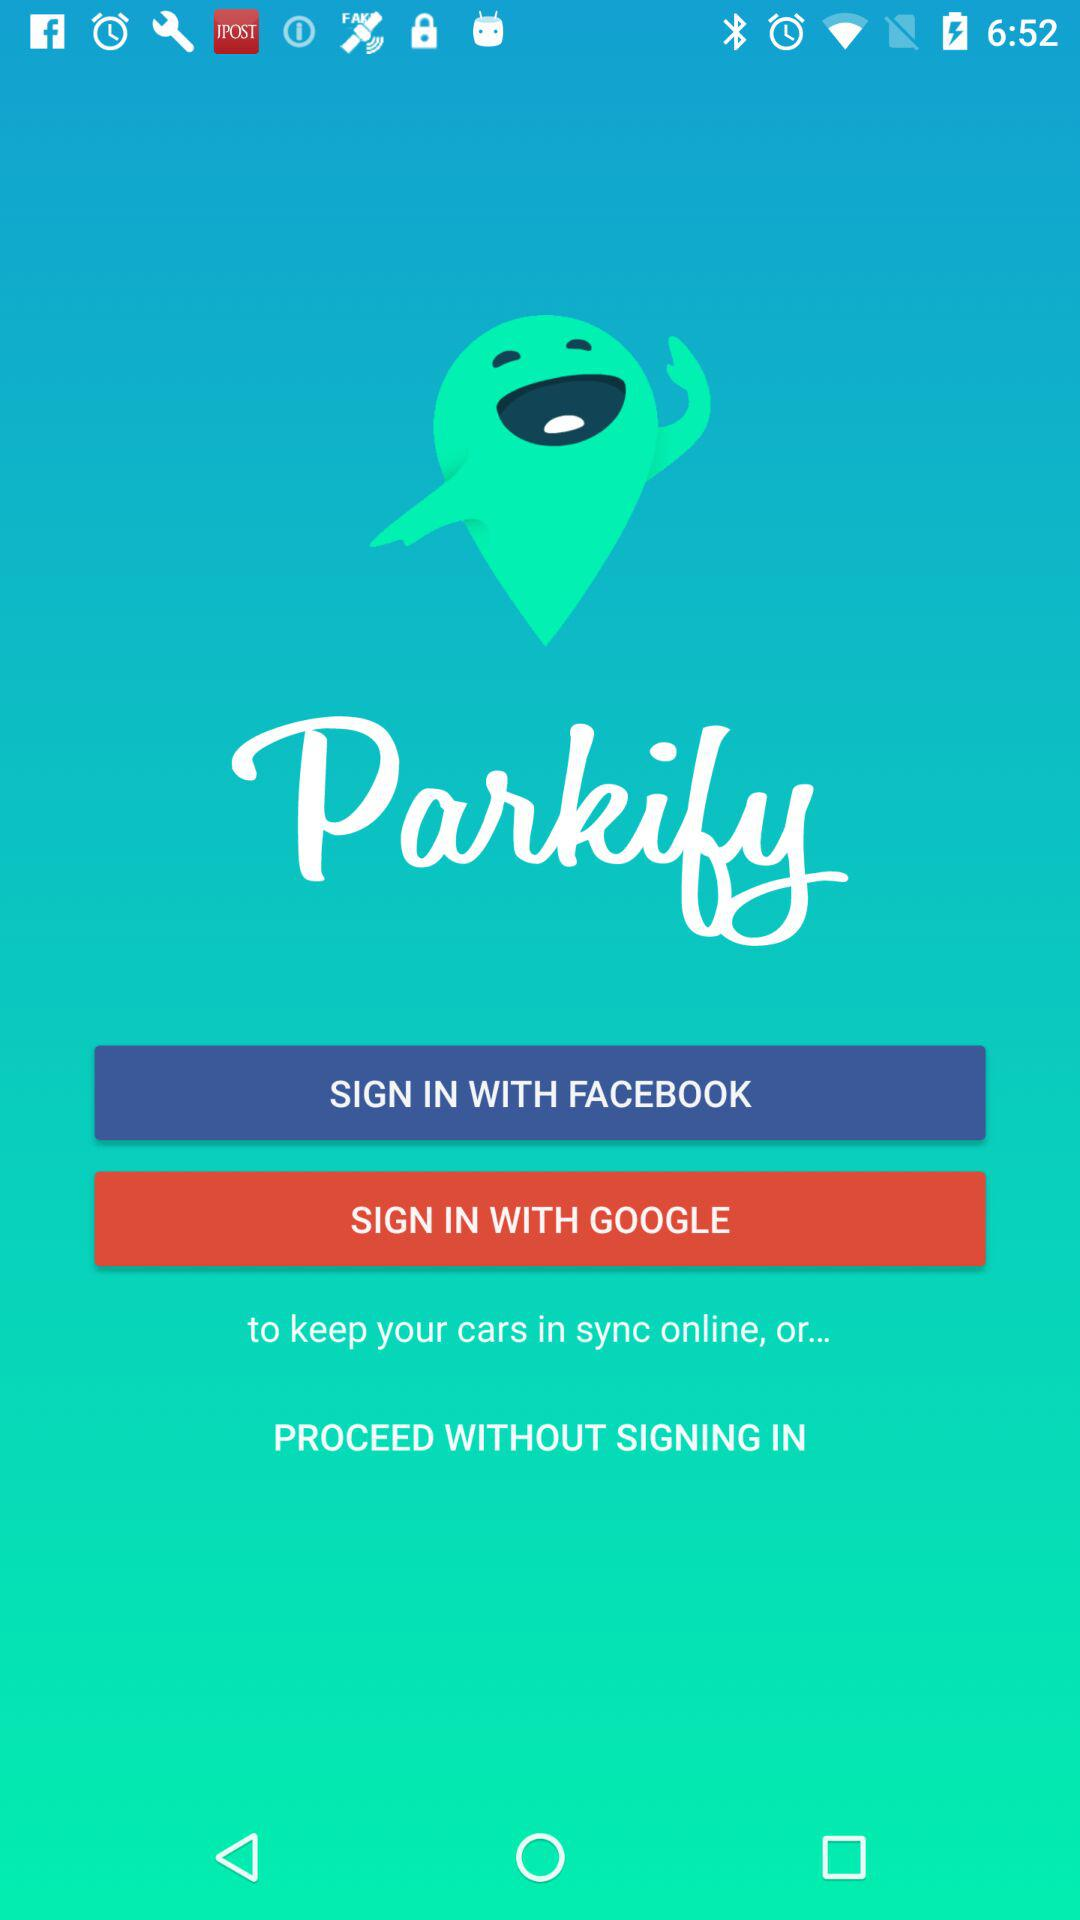Which are the different sign-in options? The different sign-in options are "FACEBOOK" and "GOOGLE". 